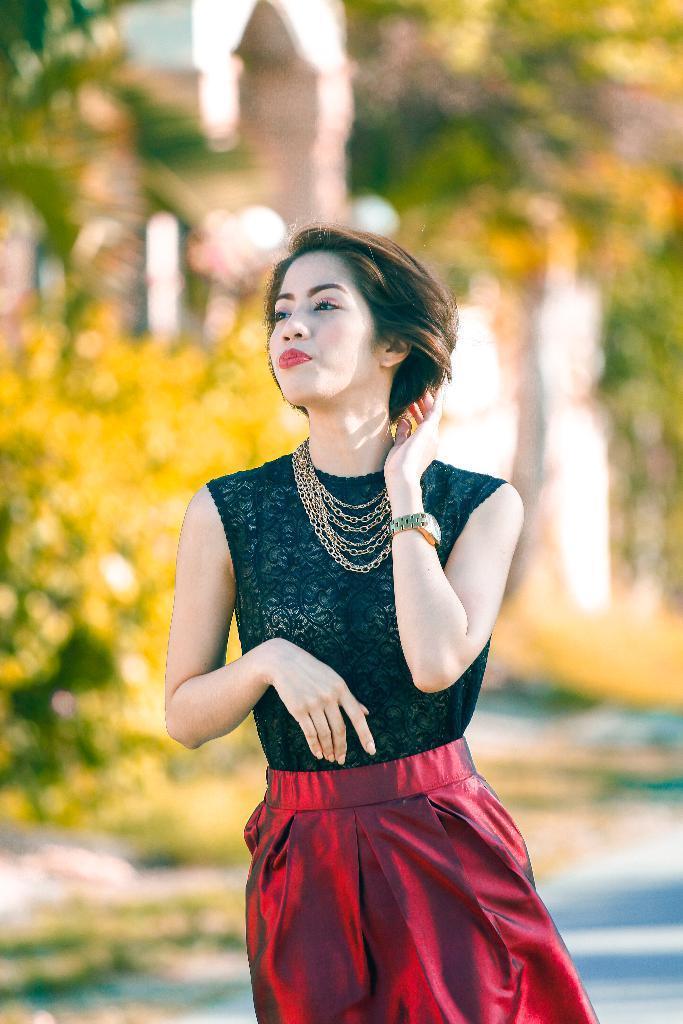Describe this image in one or two sentences. In the foreground of this image, there is a woman standing in black and red dress. In the background, there is greenery and remaining objects are not clear. 